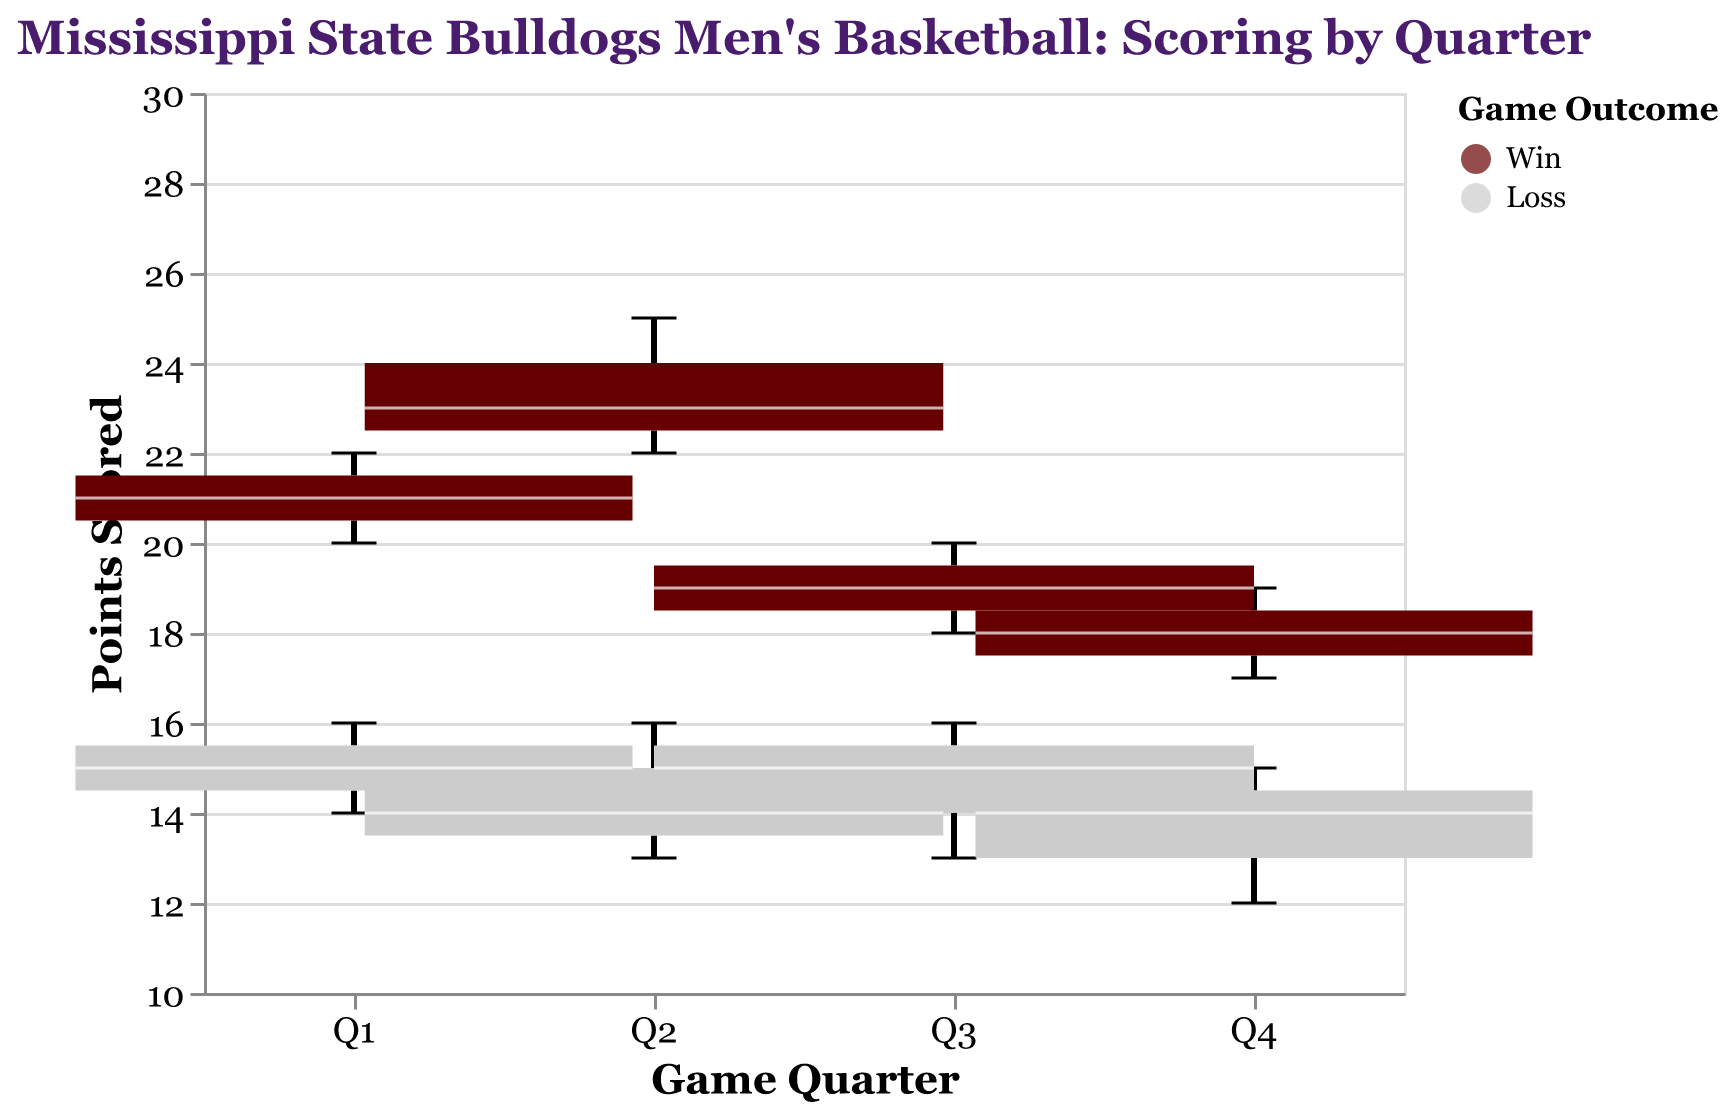What is the title of the plot? The title is located at the top of the plot and provides a summary of the content depicted in the figure.
Answer: Mississippi State Bulldogs Men's Basketball: Scoring by Quarter Which color represents the games that Mississippi State Bulldogs won? The legend at the bottom right of the plot shows the mapping between colors and game outcomes. The color "#660000" (dark maroon) corresponds to "Win".
Answer: dark maroon What are the points scored in the first quarter for the winning games? The first quarter (Q1) box plot for the 'Win' category shows the data. The box plot shows the points range from 20 to 22. So the points scored are within this range.
Answer: 20 to 22 How does the median score of the first quarter compare between winning and losing games? The first quarter (Q1) box plot shows median scores with white lines. For 'Win', the median is around 21 points. For 'Loss', it is around 15 points. Comparing these two, the median score of winning games is higher than that of losing games.
Answer: Higher in winning games What is the range of points scored in the fourth quarter for the losing games? The fourth quarter (Q4) box plot for the 'Loss' category shows a range of points. The minimum point is 12 and the maximum point is 15.
Answer: 12 to 15 Which quarter has the most variable points for the winning games? Variability in box plots can be measured by the interquartile range (IQR), which is the length of the box. For the 'Win' category, Quarter 2 (Q2) has the widest box, indicating the most variability.
Answer: Q2 Compare the points scored in the third quarter for both outcomes. Which outcome shows higher variability? For the third quarter (Q3), the 'Win' box plot has a larger IQR compared to 'Loss'. Hence, the 'Win' outcome shows higher variability in the third quarter.
Answer: Win Is there any quarter where the ranges (min to max) of points for winning and losing games overlap? By inspecting the ranges in all quarters, we can see that there are no overlaps between the 'Win' and 'Loss' categories in Q1, Q2, and Q4. For Q3, there is slight overlap around the 18-19 points mark.
Answer: Slight overlap in Q3 What is the maximum number of points scored in the second quarter of a winning game? By inspecting the second quarter (Q2) box plot under the 'Win' outcome, the maximum point is at 25.
Answer: 25 Are there any quarters where the median score for winning games is below 18 points? The median lines for all quarters can be observed. For 'Win', the medians in Q1, Q2, Q3, and Q4 are all equal to or above 18 points. Hence, there is no quarter where the median for winning games is below 18 points.
Answer: No 